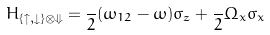<formula> <loc_0><loc_0><loc_500><loc_500>H _ { \{ \uparrow , \downarrow \} \otimes \Downarrow } = \frac { } { 2 } ( \omega _ { 1 2 } - \omega ) \sigma _ { z } + \frac { } { 2 } \Omega _ { x } \sigma _ { x }</formula> 